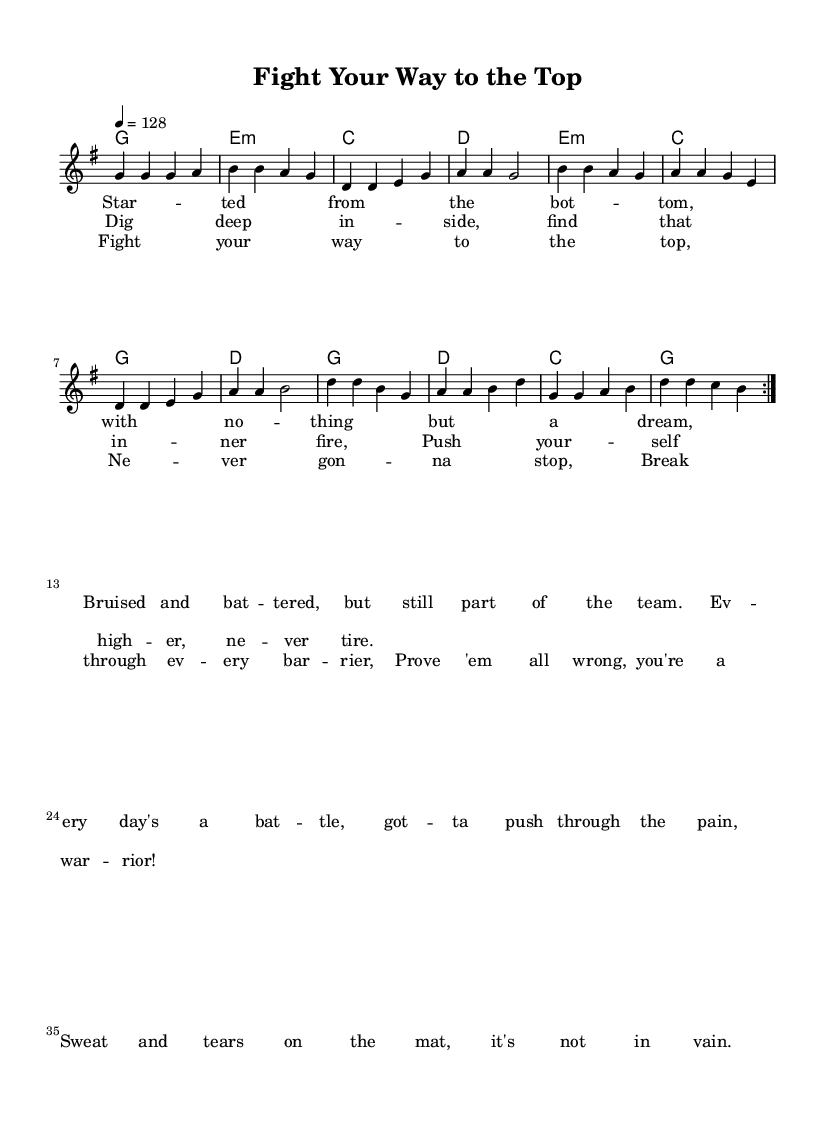what is the key signature of this music? The key signature indicates G major, which has one sharp (F#). This is determined by looking at the "g" in the key signature's indication.
Answer: G major what is the time signature of this music? The time signature is 4/4, as indicated at the beginning of the score, showing there are four beats per measure and the quarter note gets one beat.
Answer: 4/4 what is the tempo marking for this piece? The tempo marking is 128, specified at the beginning of the score, indicating the beats per minute (BPM). This specifies how fast the music should be played.
Answer: 128 how many verses are in the song? There is one verse in the sheet music, as indicated by the lyrics section and its structure. The verse is also repeated, as suggested by the volta marking.
Answer: One what is the nature of the chorus in this song? The chorus is an uplifting anthem encouraging perseverance and determination, typically found in country rock, characterized by its strong and assertive lyrics about fighting and overcoming challenges.
Answer: Uplifting anthem which section of the song uses the lyrics that encourage self-motivation? The prechorus contains lyrics focusing on digging deep and finding inner strength, which emphasize self-motivation and determination.
Answer: Prechorus how many measures are repeated in the melody section? The melody section repeats a total of eight measures as indicated by the repeat markings (volta), suggesting these measures are played twice.
Answer: Eight measures 